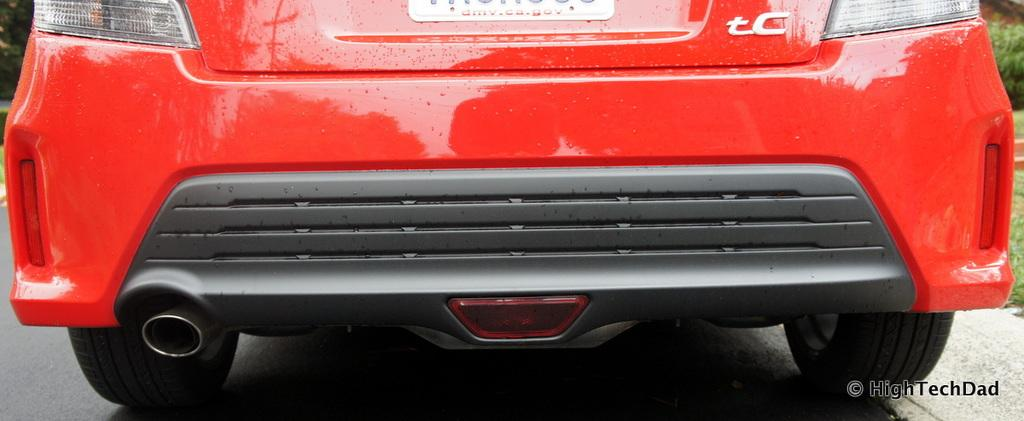What is the main subject of the image? There is a vehicle in the image. What can be seen on the vehicle? There is text on the vehicle. Where is the text located in the image? There is text in the bottom right of the image. What type of vegetation is on the right side of the image? There is grass and plants on the right side of the image. What type of noise can be heard coming from the vehicle in the image? There is no indication of sound or noise in the image, as it is a still image and does not include any audio. What shape is the vehicle in the image? The shape of the vehicle cannot be determined from the image alone, as it only provides a partial view of the vehicle. 